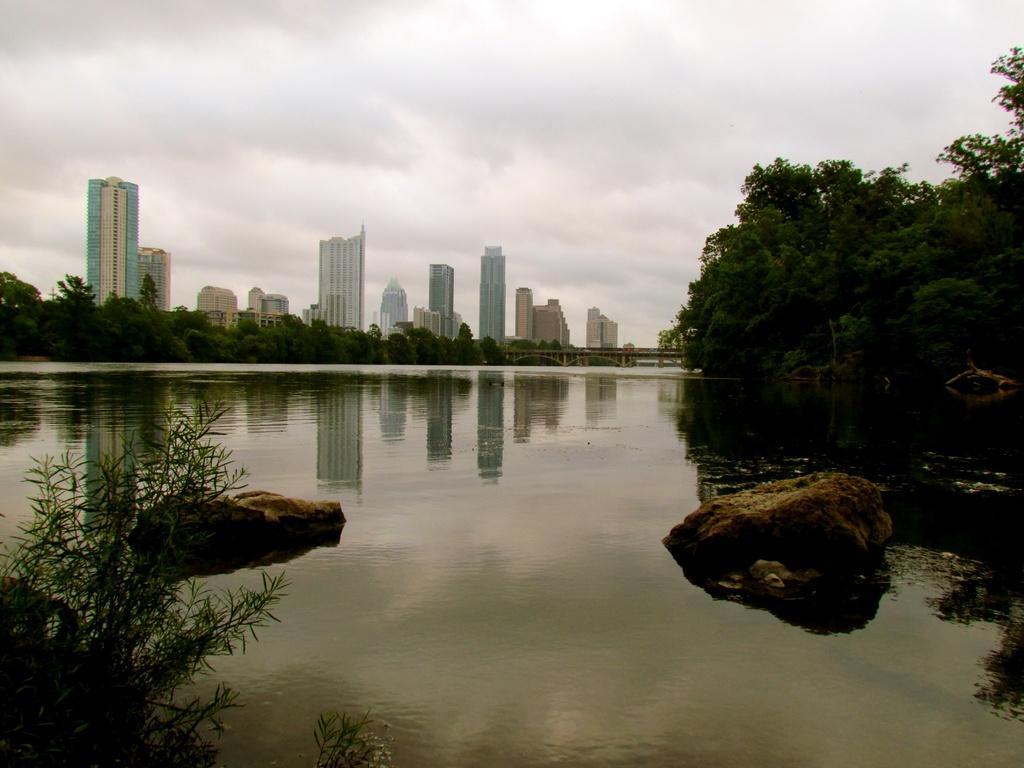Describe this image in one or two sentences. In this image, I can see the rocks on the water. In the background, there are trees, buildings, bridge and the sky. At the bottom left corner of the image, I can see a plant. 